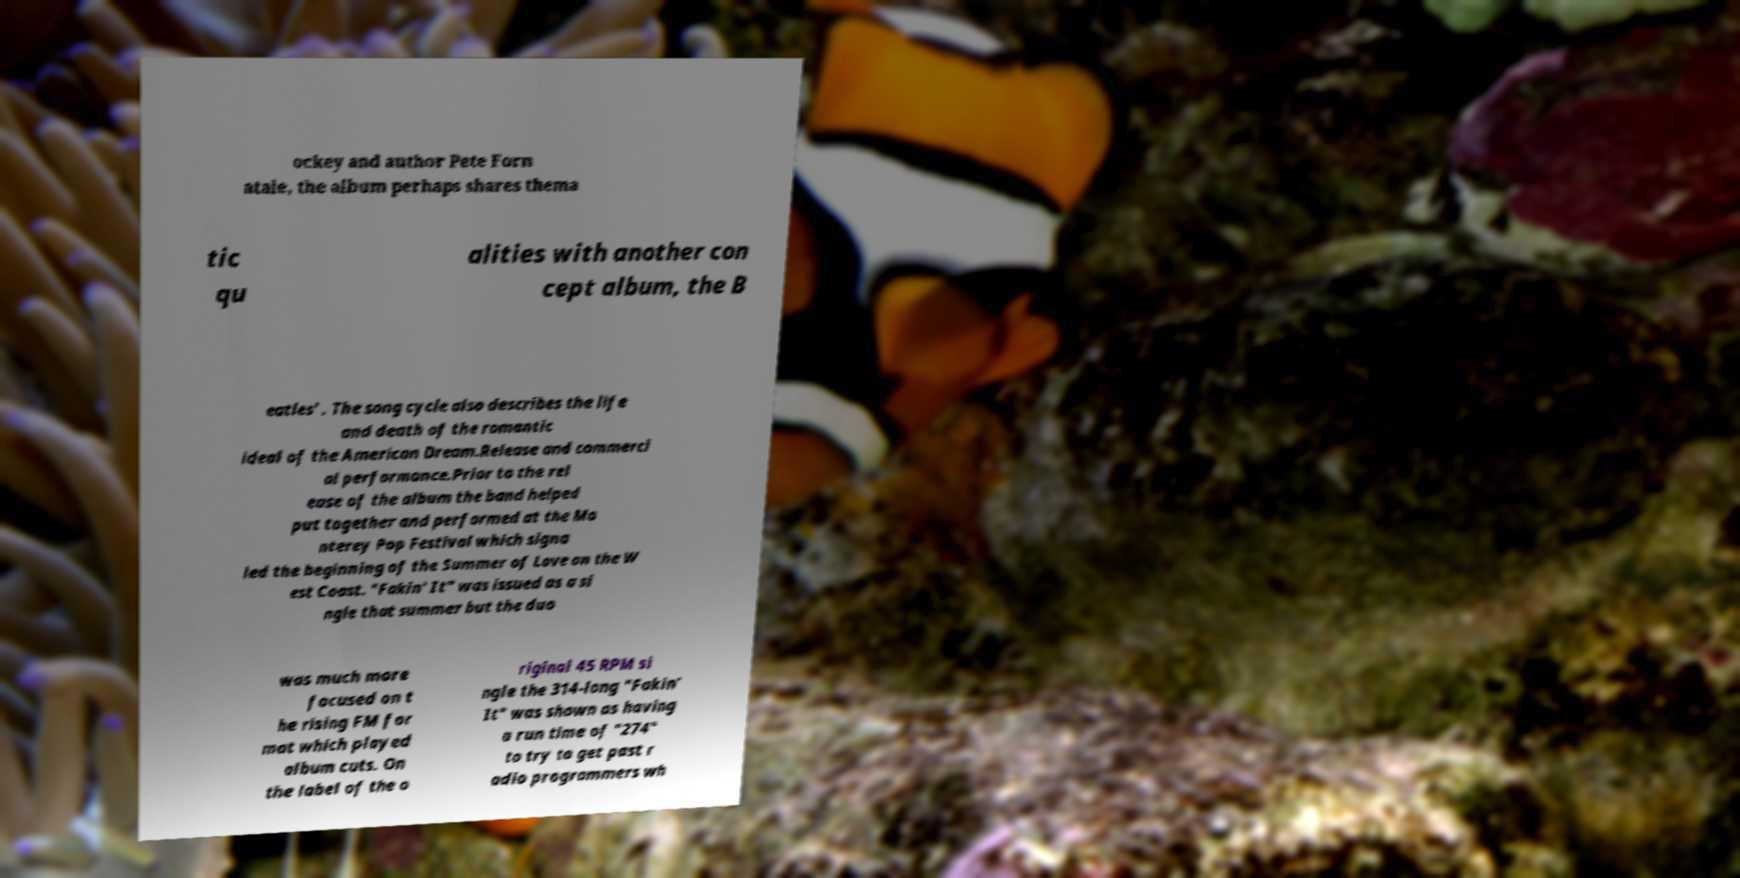There's text embedded in this image that I need extracted. Can you transcribe it verbatim? ockey and author Pete Forn atale, the album perhaps shares thema tic qu alities with another con cept album, the B eatles' . The song cycle also describes the life and death of the romantic ideal of the American Dream.Release and commerci al performance.Prior to the rel ease of the album the band helped put together and performed at the Mo nterey Pop Festival which signa led the beginning of the Summer of Love on the W est Coast. "Fakin' It" was issued as a si ngle that summer but the duo was much more focused on t he rising FM for mat which played album cuts. On the label of the o riginal 45 RPM si ngle the 314-long "Fakin' It" was shown as having a run time of "274" to try to get past r adio programmers wh 